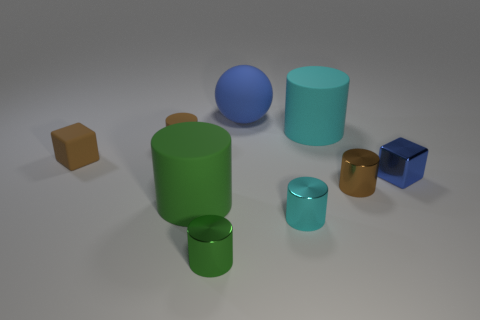Is the material of the brown block the same as the big sphere?
Your response must be concise. Yes. There is a small thing that is in front of the blue block and to the left of the small cyan object; what is it made of?
Provide a succinct answer. Metal. What is the color of the tiny shiny cylinder on the right side of the small cyan metallic cylinder?
Give a very brief answer. Brown. Are there more large cylinders behind the small matte cylinder than small red objects?
Keep it short and to the point. Yes. How many other things are there of the same size as the rubber cube?
Make the answer very short. 5. What number of green things are behind the green shiny thing?
Keep it short and to the point. 1. Is the number of big matte things in front of the small brown rubber cylinder the same as the number of large matte objects that are to the left of the tiny green shiny cylinder?
Give a very brief answer. Yes. What size is the green metallic thing that is the same shape as the small cyan metal thing?
Offer a very short reply. Small. What shape is the blue object that is in front of the cyan rubber cylinder?
Your response must be concise. Cube. Are the cyan cylinder behind the tiny matte block and the brown object in front of the blue cube made of the same material?
Your response must be concise. No. 